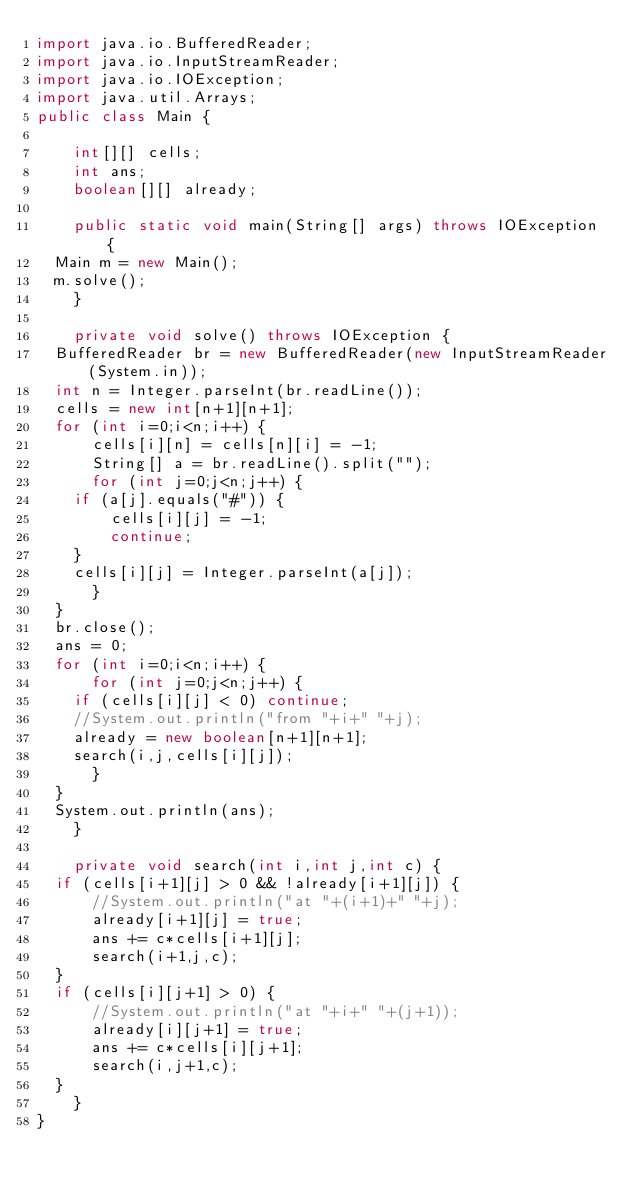<code> <loc_0><loc_0><loc_500><loc_500><_Java_>import java.io.BufferedReader;
import java.io.InputStreamReader;
import java.io.IOException;
import java.util.Arrays;
public class Main {

    int[][] cells;
    int ans;
    boolean[][] already;
    
    public static void main(String[] args) throws IOException {
	Main m = new Main();
	m.solve();
    }

    private void solve() throws IOException {
	BufferedReader br = new BufferedReader(new InputStreamReader(System.in));
	int n = Integer.parseInt(br.readLine());
	cells = new int[n+1][n+1];
	for (int i=0;i<n;i++) {
	    cells[i][n] = cells[n][i] = -1;
	    String[] a = br.readLine().split("");
	    for (int j=0;j<n;j++) {
		if (a[j].equals("#")) {
		    cells[i][j] = -1;
		    continue;
		}
		cells[i][j] = Integer.parseInt(a[j]);
	    }
	}
	br.close();
	ans = 0;
	for (int i=0;i<n;i++) {
	    for (int j=0;j<n;j++) {
		if (cells[i][j] < 0) continue;
		//System.out.println("from "+i+" "+j);
		already = new boolean[n+1][n+1];
		search(i,j,cells[i][j]);
	    }
	}
	System.out.println(ans);
    }

    private void search(int i,int j,int c) {
	if (cells[i+1][j] > 0 && !already[i+1][j]) {
	    //System.out.println("at "+(i+1)+" "+j);
	    already[i+1][j] = true;
	    ans += c*cells[i+1][j];
	    search(i+1,j,c);
	}
	if (cells[i][j+1] > 0) {
	    //System.out.println("at "+i+" "+(j+1));
	    already[i][j+1] = true;
	    ans += c*cells[i][j+1];
	    search(i,j+1,c);
	}
    }
}</code> 